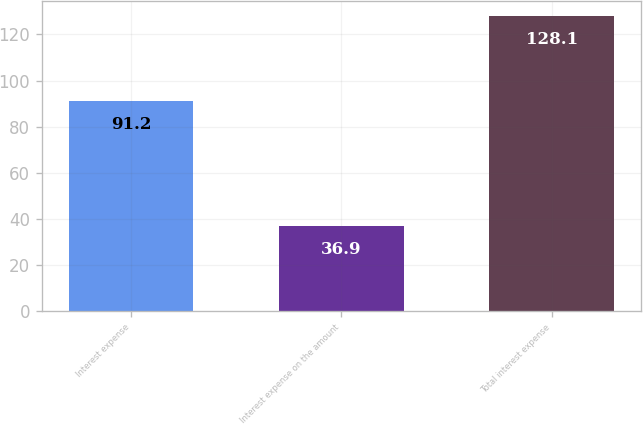<chart> <loc_0><loc_0><loc_500><loc_500><bar_chart><fcel>Interest expense<fcel>Interest expense on the amount<fcel>Total interest expense<nl><fcel>91.2<fcel>36.9<fcel>128.1<nl></chart> 